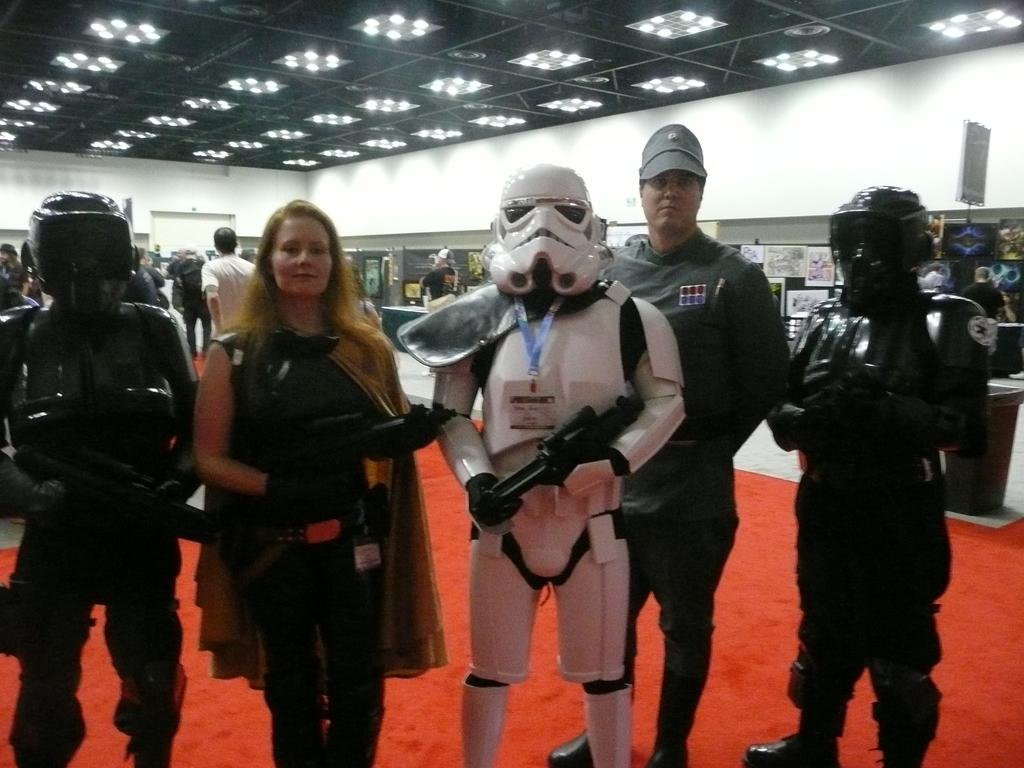Who or what can be seen in the image? There are persons and display figures in the image. What is located at the top of the image? There are lights at the top of the image. What is the government's position on the display figures in the image? The image does not provide any information about the government's position on the display figures. How many fingers can be seen on the persons in the image? The number of fingers on the persons in the image cannot be determined from the provided facts. 